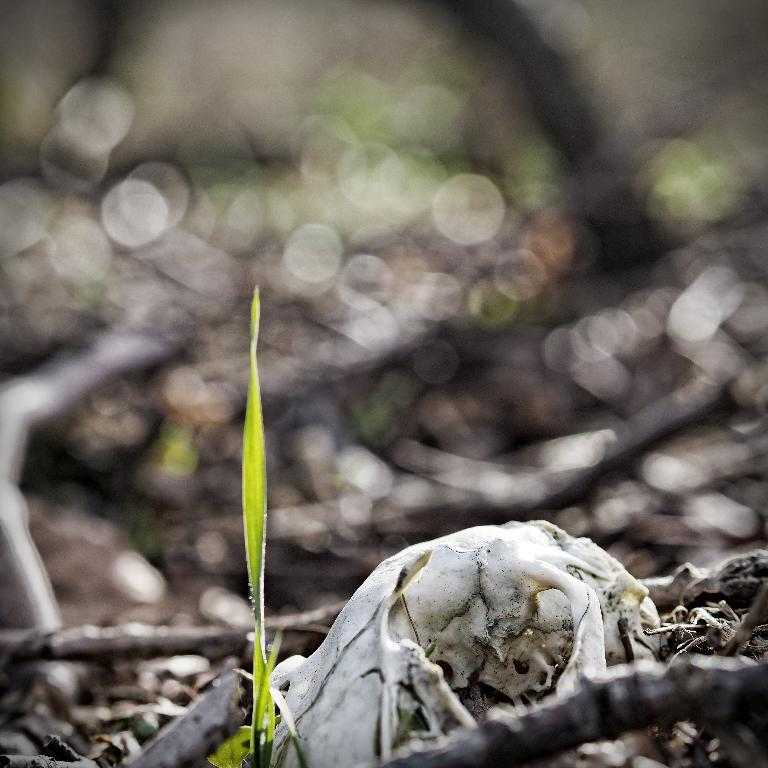What is located in the bottom left of the image? There is a leaf in the bottom left of the image. What is positioned beside the leaf in the image? There is a bone beside the leaf in the image. How many passengers are visible in the image? There are no passengers present in the image; it only features a leaf and a bone. What position does the leaf hold in relation to the bone in the image? The leaf and the bone are positioned beside each other in the image, with the leaf in the bottom left and the bone beside it. 